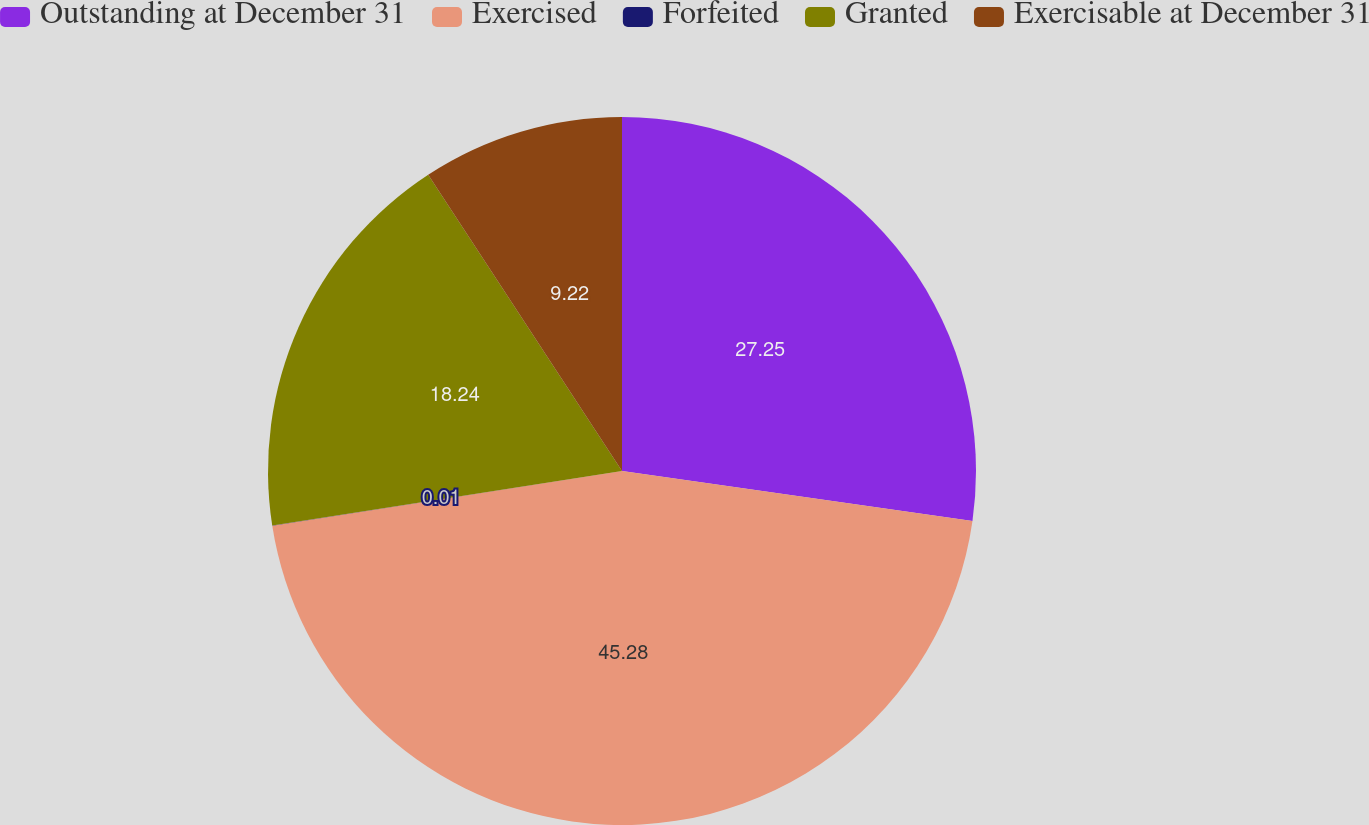<chart> <loc_0><loc_0><loc_500><loc_500><pie_chart><fcel>Outstanding at December 31<fcel>Exercised<fcel>Forfeited<fcel>Granted<fcel>Exercisable at December 31<nl><fcel>27.25%<fcel>45.28%<fcel>0.01%<fcel>18.24%<fcel>9.22%<nl></chart> 